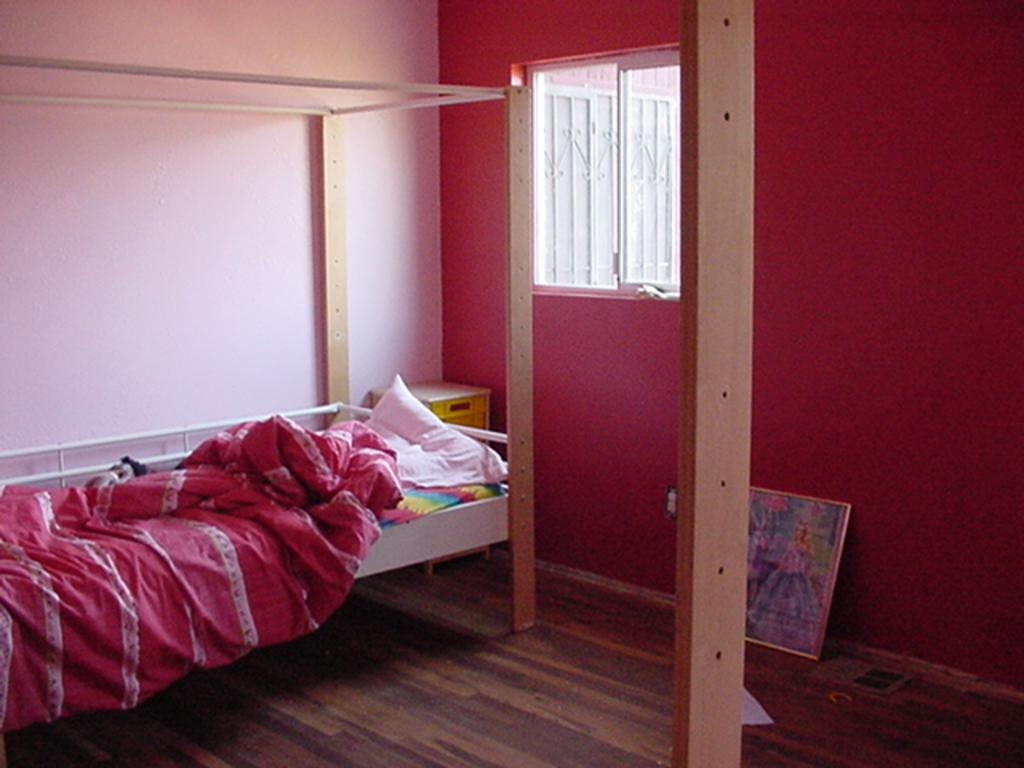What is the main object in the image? There is a photo frame in the image. What type of furniture is present in the image? There is a cot on the floor in the image. What can be seen hanging on the cot? Clothes are visible in the image. What is used for comfort while sleeping? There is a pillow in the image. What is the material of the pole in the image? There is a wooden pole in the image. What other objects can be seen in the image? There are other objects in the image, but their specific details are not mentioned in the facts. What is visible in the background of the image? There is a wall and a window in the background of the image. What type of flower is growing on the pillow in the image? There is no flower present on the pillow in the image. 